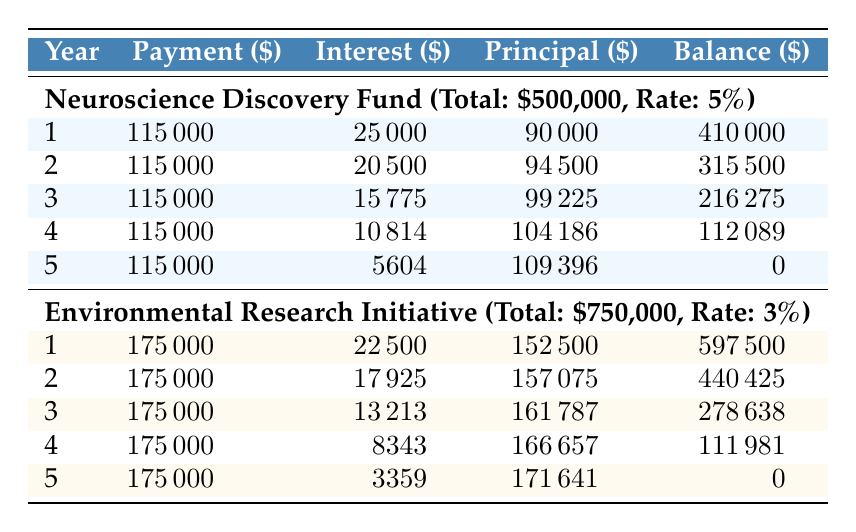What is the total amount of the Neuroscience Discovery Fund grant? The total amount for the Neuroscience Discovery Fund grant is listed in the first row under the grant details as $500,000.
Answer: 500000 In which year was the highest principal repayment made for the Environmental Research Initiative? The principal repayments for each year are: Year 1: $152,500, Year 2: $157,075, Year 3: $161,787, Year 4: $166,657, Year 5: $171,641. The highest repayment is in Year 5 at $171,641.
Answer: Year 5 What is the sum of all annual payments for the Neuroscience Discovery Fund grant? The annual payments for the Neuroscience Discovery Fund are $115,000 each year for 5 years. The sum is 115,000 * 5 = $575,000.
Answer: 575000 Did the Environmental Research Initiative incur more interest payment in the first year compared to the Neuroscience Discovery Fund? The interest payment for the Environmental Research Initiative in Year 1 is $22,500, whereas for the Neuroscience Discovery Fund it is $25,000. Since $25,000 > $22,500, the statement is true.
Answer: Yes What is the remaining balance after the third year's payment for the Neuroscience Discovery Fund? In Year 3, the remaining balance is noted in the annual payments as $216,275 after the payment has been made.
Answer: 216275 What is the average annual payment for the Environmental Research Initiative over the five years? The total annual payment over five years is $175,000 * 5 = $875,000. To find the average, divide this by 5, so the average payment is $875,000 / 5 = $175,000.
Answer: 175000 Which grant has a lower interest rate and what is the rate? The Environmental Research Initiative has an interest rate of 3%, which is lower than the Neuroscience Discovery Fund's rate of 5%.
Answer: 3% How much total interest is paid over the five years for the Neuroscience Discovery Fund? The interest payments for each of the five years are: Year 1: $25,000, Year 2: $20,500, Year 3: $15,775, Year 4: $10,814, Year 5: $5,604. Adding these gives $25,000 + $20,500 + $15,775 + $10,814 + $5,604 = $77,693.
Answer: 77693 